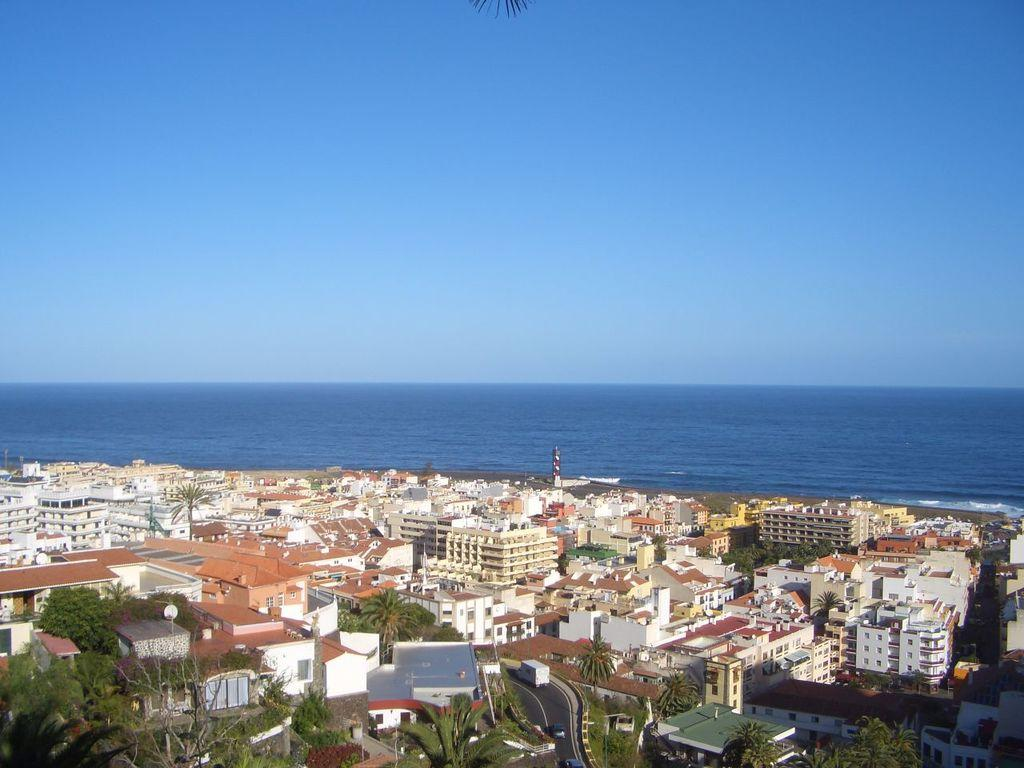What type of structures can be seen in the image? There are buildings in the image. What natural elements are present in the image? There are trees in the image. What is the surface on which the buildings and trees are situated? The ground is visible in the image. What mode of transportation can be seen in the image? There are vehicles in the image. What body of water is visible in the image? There is water visible in the image. What part of the natural environment is visible in the image? The sky is visible in the image. Can you tell me how many boats are in the image? There are no boats present in the image. What role does the brother play in the image? There is no mention of a brother in the image or the provided facts. 